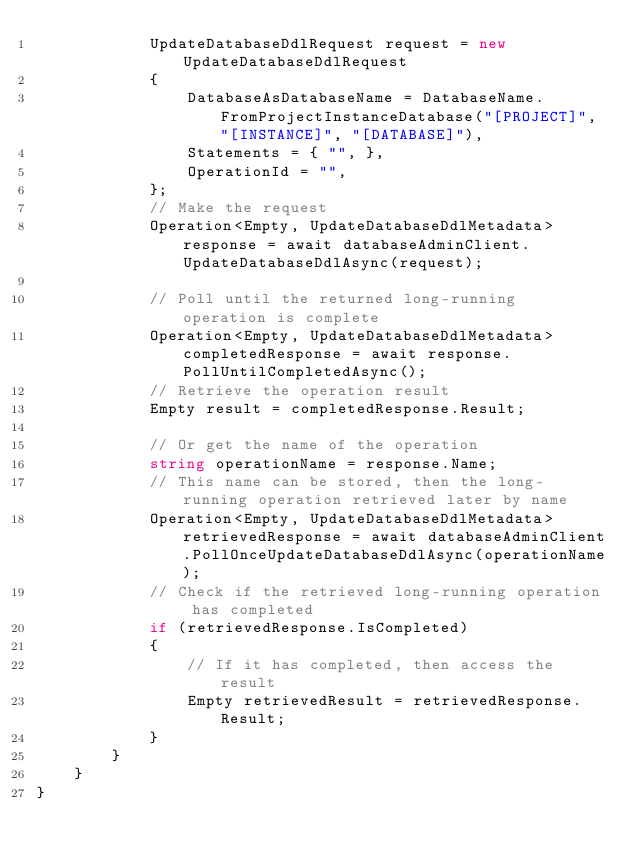Convert code to text. <code><loc_0><loc_0><loc_500><loc_500><_C#_>            UpdateDatabaseDdlRequest request = new UpdateDatabaseDdlRequest
            {
                DatabaseAsDatabaseName = DatabaseName.FromProjectInstanceDatabase("[PROJECT]", "[INSTANCE]", "[DATABASE]"),
                Statements = { "", },
                OperationId = "",
            };
            // Make the request
            Operation<Empty, UpdateDatabaseDdlMetadata> response = await databaseAdminClient.UpdateDatabaseDdlAsync(request);

            // Poll until the returned long-running operation is complete
            Operation<Empty, UpdateDatabaseDdlMetadata> completedResponse = await response.PollUntilCompletedAsync();
            // Retrieve the operation result
            Empty result = completedResponse.Result;

            // Or get the name of the operation
            string operationName = response.Name;
            // This name can be stored, then the long-running operation retrieved later by name
            Operation<Empty, UpdateDatabaseDdlMetadata> retrievedResponse = await databaseAdminClient.PollOnceUpdateDatabaseDdlAsync(operationName);
            // Check if the retrieved long-running operation has completed
            if (retrievedResponse.IsCompleted)
            {
                // If it has completed, then access the result
                Empty retrievedResult = retrievedResponse.Result;
            }
        }
    }
}
</code> 